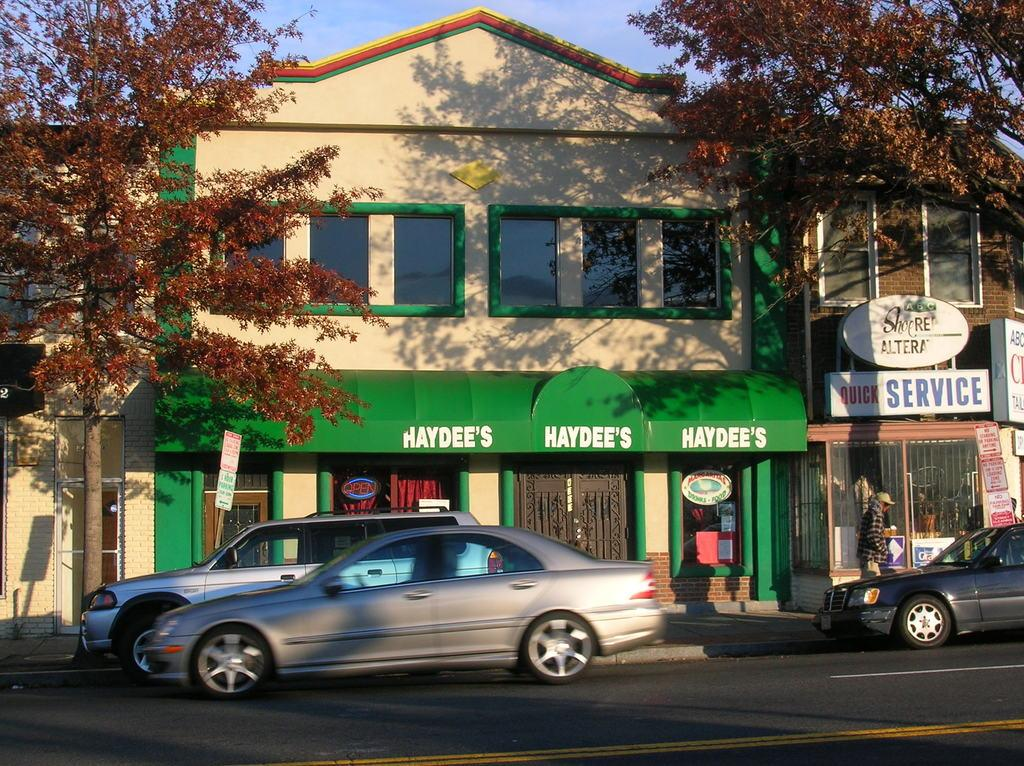What type of vehicles can be seen on the road in the image? There are cars on the road in the image. What objects are visible in the image besides the cars? Boards, trees, buildings, and a person walking are visible in the image. Can you describe the person walking in the image? There is a person walking in the image. What is visible at the top of the image? The sky is visible at the top of the image. What type of air is being used to lift the cars in the image? There is no air lifting the cars in the image; they are on the road. Is there a veil covering the trees in the image? There is no veil present in the image; the trees are visible. 